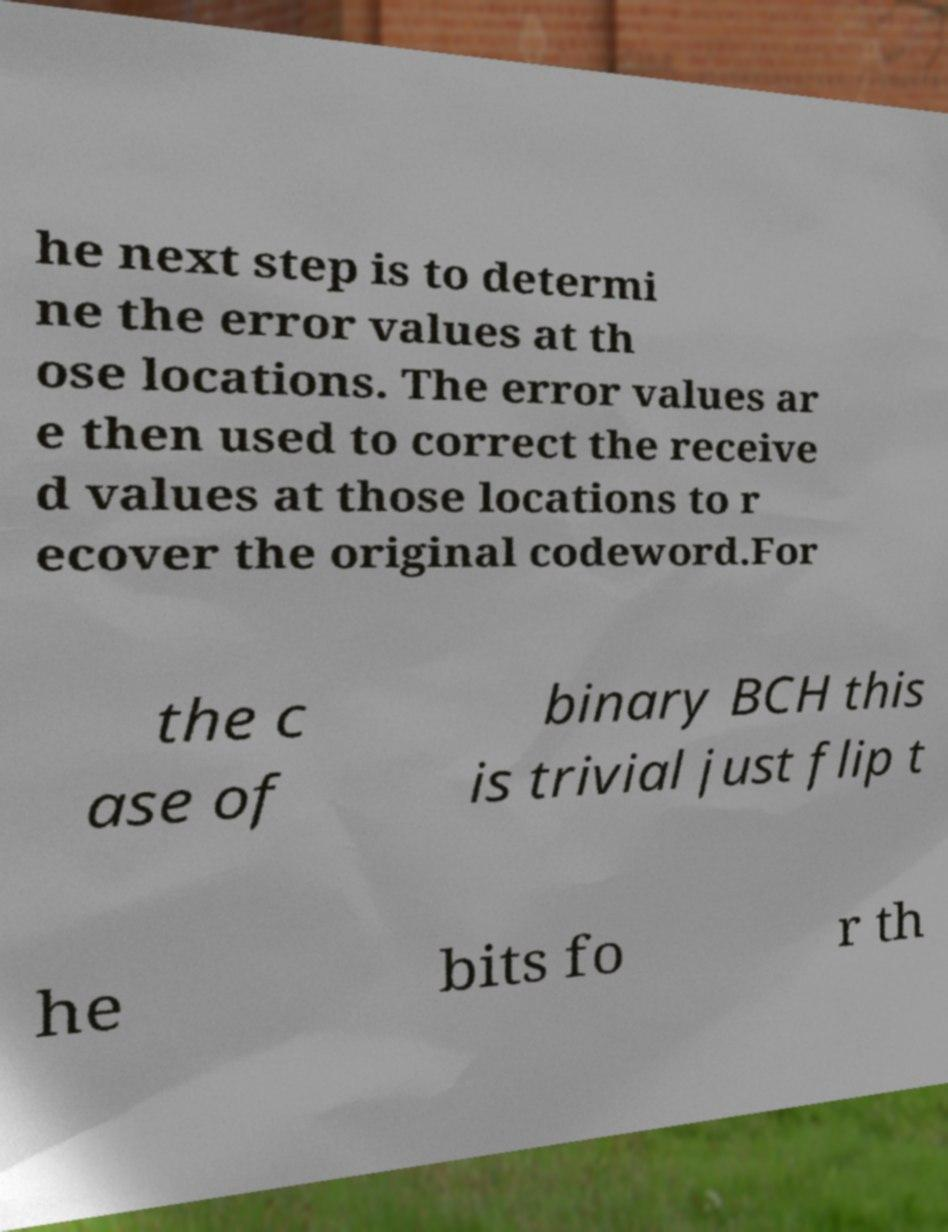Can you read and provide the text displayed in the image?This photo seems to have some interesting text. Can you extract and type it out for me? he next step is to determi ne the error values at th ose locations. The error values ar e then used to correct the receive d values at those locations to r ecover the original codeword.For the c ase of binary BCH this is trivial just flip t he bits fo r th 